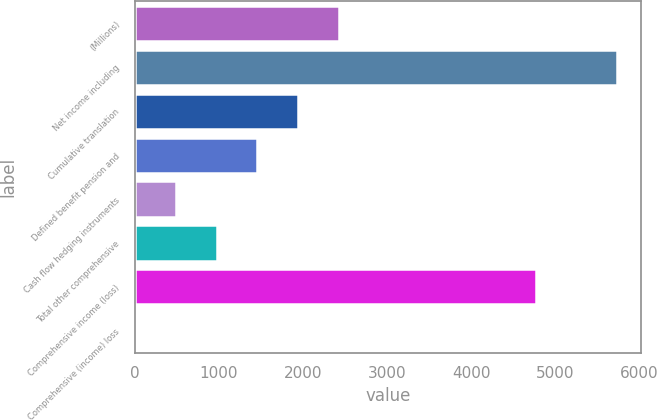Convert chart to OTSL. <chart><loc_0><loc_0><loc_500><loc_500><bar_chart><fcel>(Millions)<fcel>Net income including<fcel>Cumulative translation<fcel>Defined benefit pension and<fcel>Cash flow hedging instruments<fcel>Total other comprehensive<fcel>Comprehensive income (loss)<fcel>Comprehensive (income) loss<nl><fcel>2423.5<fcel>5730<fcel>1940<fcel>1456.5<fcel>489.5<fcel>973<fcel>4763<fcel>6<nl></chart> 